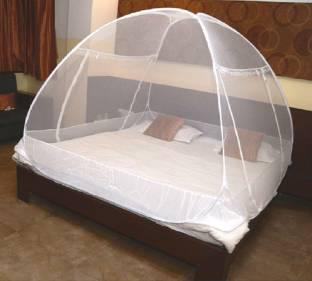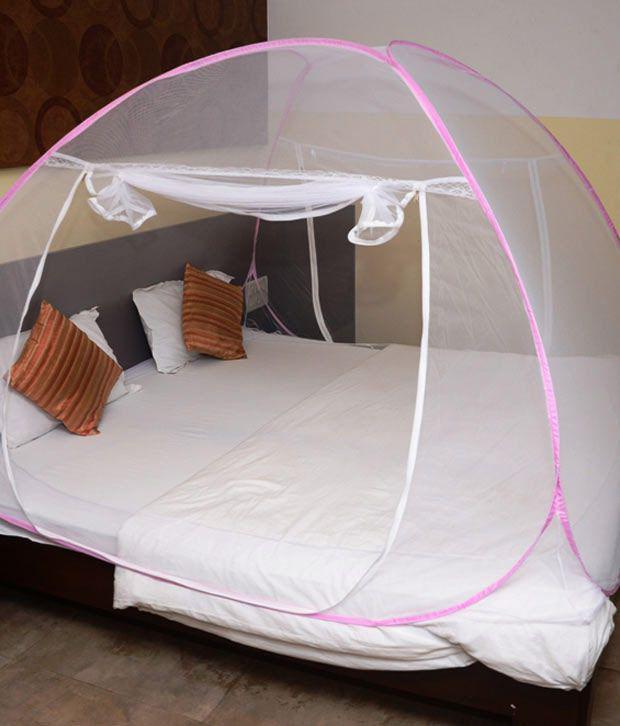The first image is the image on the left, the second image is the image on the right. Considering the images on both sides, is "Each image shows a bed with a rounded dome-shaped canopy with non-dark trim over its mattress, and one bed is positioned at a leftward angle." valid? Answer yes or no. Yes. The first image is the image on the left, the second image is the image on the right. Considering the images on both sides, is "In each image, an igloo-shaped net cover is positioned over a double bed with brown and white pillows." valid? Answer yes or no. Yes. 